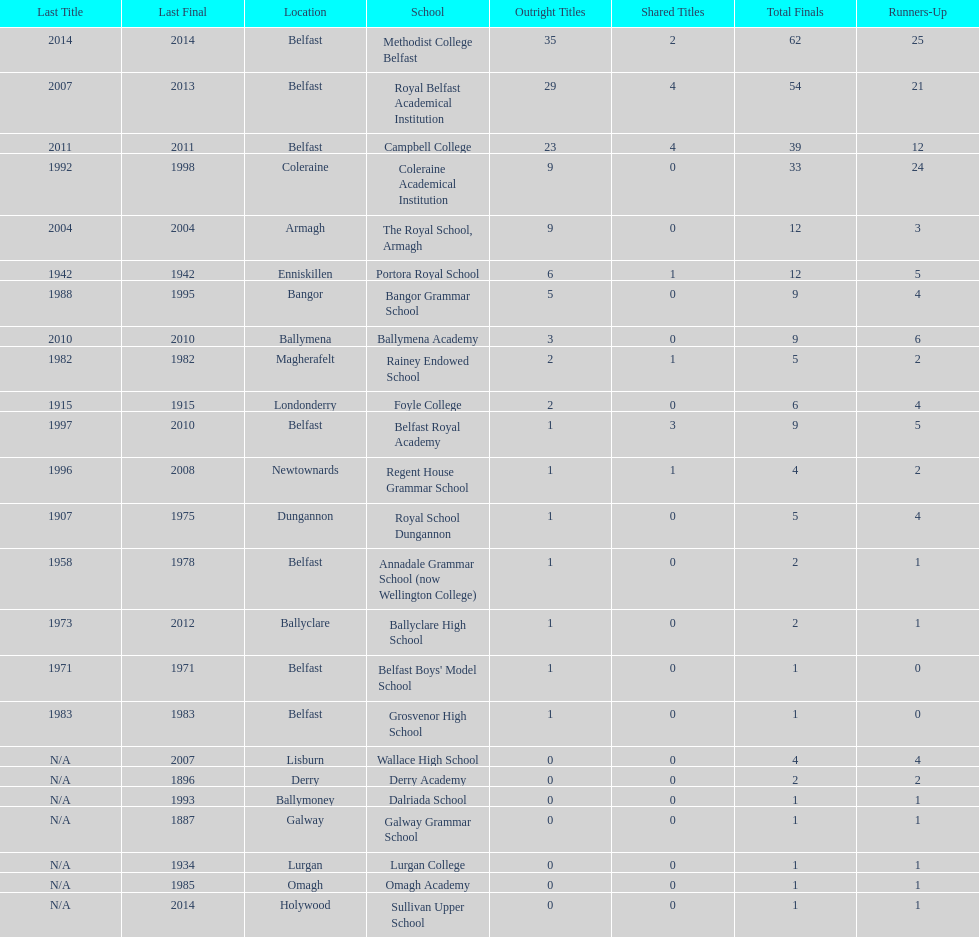What was the last year that the regent house grammar school won a title? 1996. Would you mind parsing the complete table? {'header': ['Last Title', 'Last Final', 'Location', 'School', 'Outright Titles', 'Shared Titles', 'Total Finals', 'Runners-Up'], 'rows': [['2014', '2014', 'Belfast', 'Methodist College Belfast', '35', '2', '62', '25'], ['2007', '2013', 'Belfast', 'Royal Belfast Academical Institution', '29', '4', '54', '21'], ['2011', '2011', 'Belfast', 'Campbell College', '23', '4', '39', '12'], ['1992', '1998', 'Coleraine', 'Coleraine Academical Institution', '9', '0', '33', '24'], ['2004', '2004', 'Armagh', 'The Royal School, Armagh', '9', '0', '12', '3'], ['1942', '1942', 'Enniskillen', 'Portora Royal School', '6', '1', '12', '5'], ['1988', '1995', 'Bangor', 'Bangor Grammar School', '5', '0', '9', '4'], ['2010', '2010', 'Ballymena', 'Ballymena Academy', '3', '0', '9', '6'], ['1982', '1982', 'Magherafelt', 'Rainey Endowed School', '2', '1', '5', '2'], ['1915', '1915', 'Londonderry', 'Foyle College', '2', '0', '6', '4'], ['1997', '2010', 'Belfast', 'Belfast Royal Academy', '1', '3', '9', '5'], ['1996', '2008', 'Newtownards', 'Regent House Grammar School', '1', '1', '4', '2'], ['1907', '1975', 'Dungannon', 'Royal School Dungannon', '1', '0', '5', '4'], ['1958', '1978', 'Belfast', 'Annadale Grammar School (now Wellington College)', '1', '0', '2', '1'], ['1973', '2012', 'Ballyclare', 'Ballyclare High School', '1', '0', '2', '1'], ['1971', '1971', 'Belfast', "Belfast Boys' Model School", '1', '0', '1', '0'], ['1983', '1983', 'Belfast', 'Grosvenor High School', '1', '0', '1', '0'], ['N/A', '2007', 'Lisburn', 'Wallace High School', '0', '0', '4', '4'], ['N/A', '1896', 'Derry', 'Derry Academy', '0', '0', '2', '2'], ['N/A', '1993', 'Ballymoney', 'Dalriada School', '0', '0', '1', '1'], ['N/A', '1887', 'Galway', 'Galway Grammar School', '0', '0', '1', '1'], ['N/A', '1934', 'Lurgan', 'Lurgan College', '0', '0', '1', '1'], ['N/A', '1985', 'Omagh', 'Omagh Academy', '0', '0', '1', '1'], ['N/A', '2014', 'Holywood', 'Sullivan Upper School', '0', '0', '1', '1']]} 